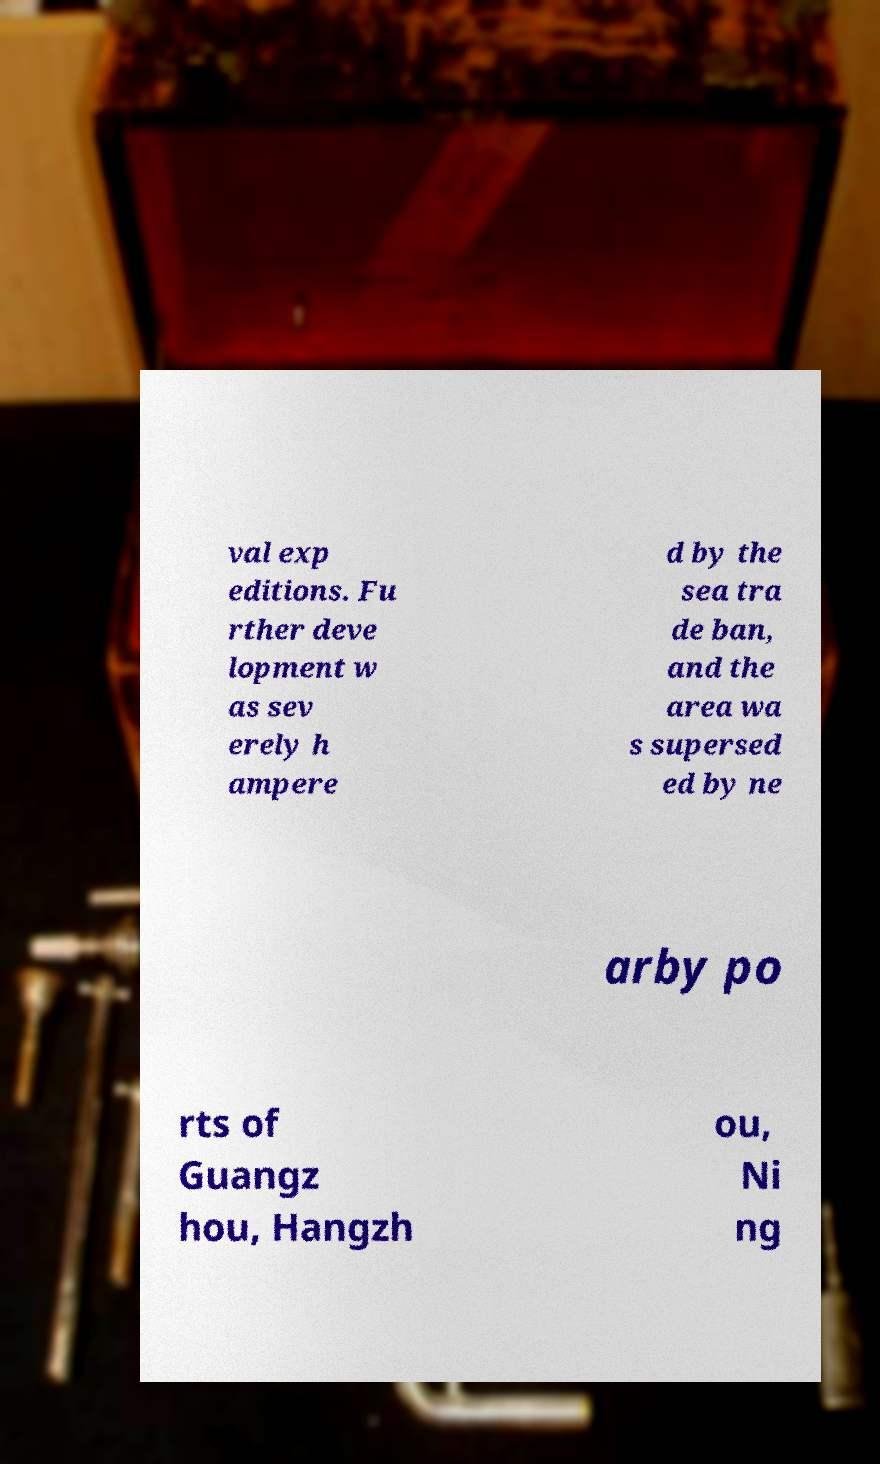Please identify and transcribe the text found in this image. val exp editions. Fu rther deve lopment w as sev erely h ampere d by the sea tra de ban, and the area wa s supersed ed by ne arby po rts of Guangz hou, Hangzh ou, Ni ng 